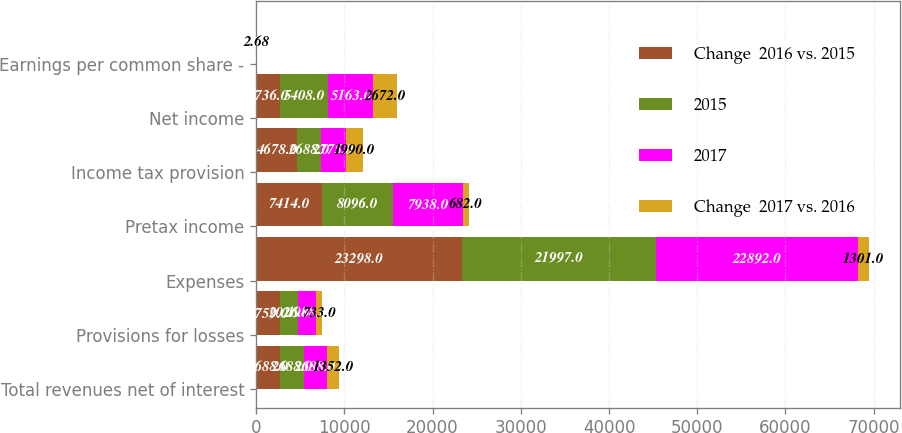Convert chart to OTSL. <chart><loc_0><loc_0><loc_500><loc_500><stacked_bar_chart><ecel><fcel>Total revenues net of interest<fcel>Provisions for losses<fcel>Expenses<fcel>Pretax income<fcel>Income tax provision<fcel>Net income<fcel>Earnings per common share -<nl><fcel>Change  2016 vs. 2015<fcel>2688<fcel>2759<fcel>23298<fcel>7414<fcel>4678<fcel>2736<fcel>2.97<nl><fcel>2015<fcel>2688<fcel>2026<fcel>21997<fcel>8096<fcel>2688<fcel>5408<fcel>5.65<nl><fcel>2017<fcel>2688<fcel>1988<fcel>22892<fcel>7938<fcel>2775<fcel>5163<fcel>5.05<nl><fcel>Change  2017 vs. 2016<fcel>1352<fcel>733<fcel>1301<fcel>682<fcel>1990<fcel>2672<fcel>2.68<nl></chart> 